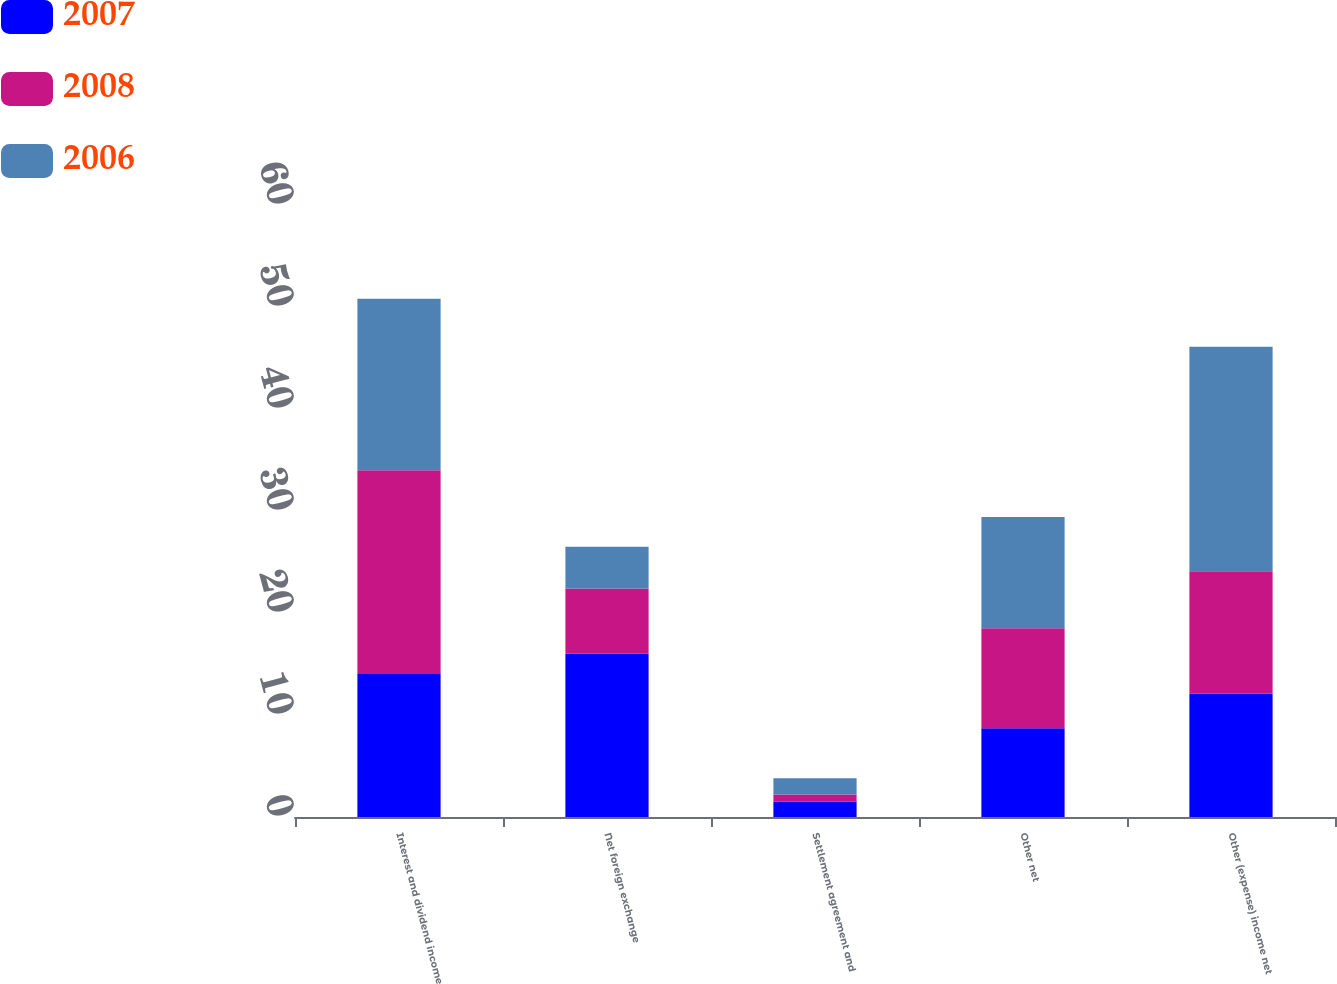<chart> <loc_0><loc_0><loc_500><loc_500><stacked_bar_chart><ecel><fcel>Interest and dividend income<fcel>Net foreign exchange<fcel>Settlement agreement and<fcel>Other net<fcel>Other (expense) income net<nl><fcel>2007<fcel>14.1<fcel>16<fcel>1.5<fcel>8.7<fcel>12.1<nl><fcel>2008<fcel>19.9<fcel>6.4<fcel>0.7<fcel>9.8<fcel>12<nl><fcel>2006<fcel>16.8<fcel>4.1<fcel>1.6<fcel>10.9<fcel>22<nl></chart> 